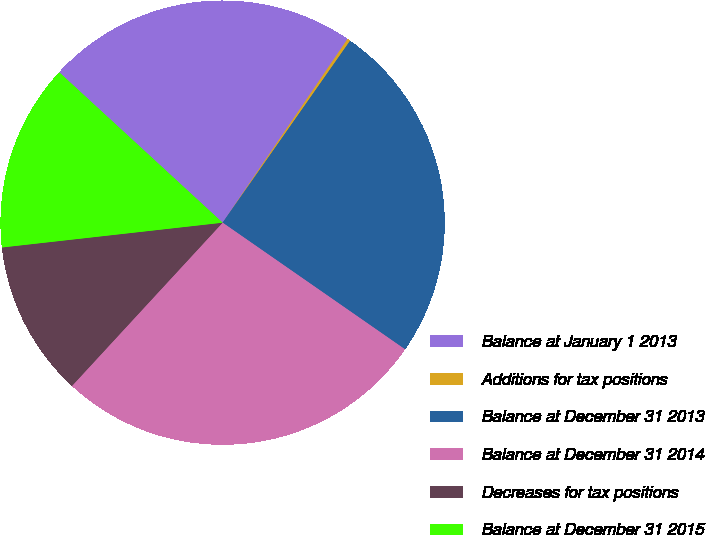<chart> <loc_0><loc_0><loc_500><loc_500><pie_chart><fcel>Balance at January 1 2013<fcel>Additions for tax positions<fcel>Balance at December 31 2013<fcel>Balance at December 31 2014<fcel>Decreases for tax positions<fcel>Balance at December 31 2015<nl><fcel>22.67%<fcel>0.22%<fcel>24.93%<fcel>27.2%<fcel>11.36%<fcel>13.62%<nl></chart> 